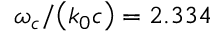Convert formula to latex. <formula><loc_0><loc_0><loc_500><loc_500>\omega _ { c } / { \left ( k _ { 0 } c \right ) } = 2 . 3 3 4</formula> 